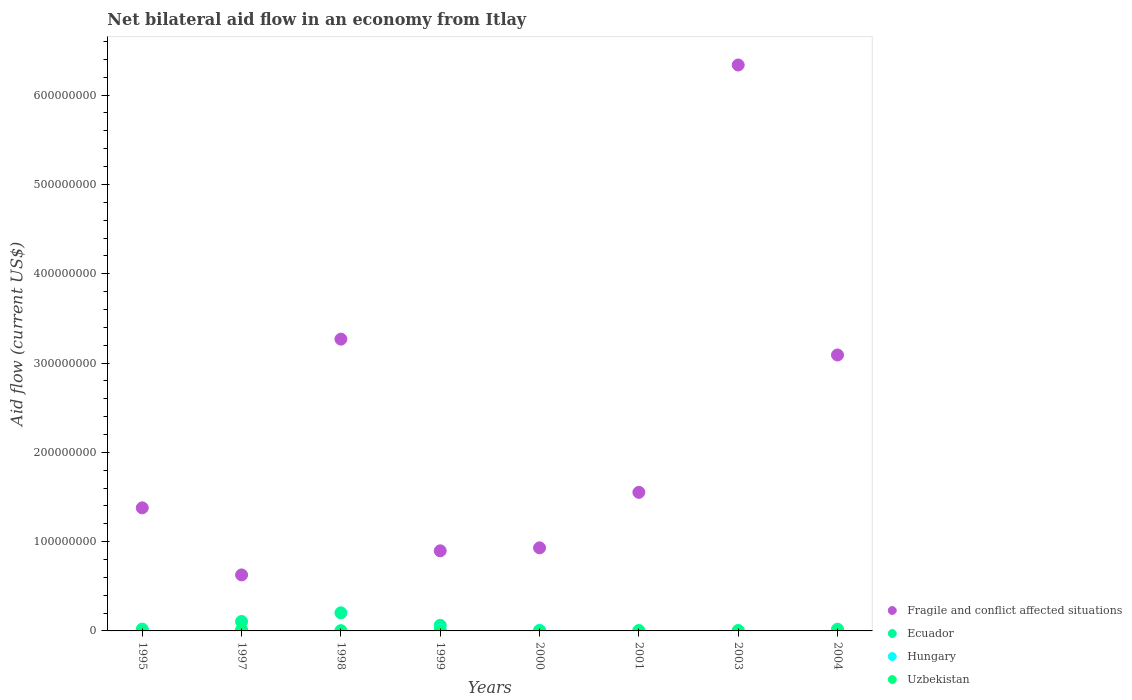How many different coloured dotlines are there?
Make the answer very short. 4. Is the number of dotlines equal to the number of legend labels?
Make the answer very short. No. Across all years, what is the maximum net bilateral aid flow in Hungary?
Your answer should be very brief. 8.90e+05. What is the total net bilateral aid flow in Ecuador in the graph?
Keep it short and to the point. 4.11e+07. What is the difference between the net bilateral aid flow in Uzbekistan in 1997 and that in 1998?
Offer a terse response. 1.13e+06. What is the difference between the net bilateral aid flow in Fragile and conflict affected situations in 1997 and the net bilateral aid flow in Ecuador in 1999?
Your answer should be very brief. 5.64e+07. What is the average net bilateral aid flow in Fragile and conflict affected situations per year?
Keep it short and to the point. 2.26e+08. In how many years, is the net bilateral aid flow in Fragile and conflict affected situations greater than 620000000 US$?
Provide a succinct answer. 1. What is the ratio of the net bilateral aid flow in Hungary in 1995 to that in 1999?
Your response must be concise. 0.37. Is the difference between the net bilateral aid flow in Uzbekistan in 1997 and 2003 greater than the difference between the net bilateral aid flow in Hungary in 1997 and 2003?
Offer a terse response. Yes. What is the difference between the highest and the second highest net bilateral aid flow in Fragile and conflict affected situations?
Offer a very short reply. 3.07e+08. What is the difference between the highest and the lowest net bilateral aid flow in Ecuador?
Provide a short and direct response. 2.03e+07. Does the net bilateral aid flow in Hungary monotonically increase over the years?
Keep it short and to the point. No. How many dotlines are there?
Your answer should be very brief. 4. Are the values on the major ticks of Y-axis written in scientific E-notation?
Offer a very short reply. No. Where does the legend appear in the graph?
Offer a very short reply. Bottom right. How many legend labels are there?
Your answer should be very brief. 4. What is the title of the graph?
Keep it short and to the point. Net bilateral aid flow in an economy from Itlay. What is the label or title of the X-axis?
Your answer should be very brief. Years. What is the Aid flow (current US$) in Fragile and conflict affected situations in 1995?
Keep it short and to the point. 1.38e+08. What is the Aid flow (current US$) of Ecuador in 1995?
Your response must be concise. 2.02e+06. What is the Aid flow (current US$) in Uzbekistan in 1995?
Your response must be concise. 10000. What is the Aid flow (current US$) of Fragile and conflict affected situations in 1997?
Your response must be concise. 6.27e+07. What is the Aid flow (current US$) of Ecuador in 1997?
Offer a very short reply. 1.06e+07. What is the Aid flow (current US$) of Hungary in 1997?
Offer a terse response. 2.60e+05. What is the Aid flow (current US$) of Uzbekistan in 1997?
Your answer should be very brief. 1.17e+06. What is the Aid flow (current US$) of Fragile and conflict affected situations in 1998?
Offer a very short reply. 3.27e+08. What is the Aid flow (current US$) in Ecuador in 1998?
Offer a very short reply. 2.03e+07. What is the Aid flow (current US$) of Hungary in 1998?
Give a very brief answer. 2.00e+05. What is the Aid flow (current US$) of Fragile and conflict affected situations in 1999?
Your response must be concise. 8.97e+07. What is the Aid flow (current US$) of Ecuador in 1999?
Offer a very short reply. 6.26e+06. What is the Aid flow (current US$) in Hungary in 1999?
Offer a terse response. 8.90e+05. What is the Aid flow (current US$) of Fragile and conflict affected situations in 2000?
Your answer should be very brief. 9.30e+07. What is the Aid flow (current US$) in Hungary in 2000?
Offer a terse response. 7.20e+05. What is the Aid flow (current US$) in Uzbekistan in 2000?
Offer a terse response. 10000. What is the Aid flow (current US$) of Fragile and conflict affected situations in 2001?
Your answer should be very brief. 1.55e+08. What is the Aid flow (current US$) of Ecuador in 2001?
Offer a very short reply. 0. What is the Aid flow (current US$) of Hungary in 2001?
Offer a terse response. 3.30e+05. What is the Aid flow (current US$) in Uzbekistan in 2001?
Your answer should be compact. 1.80e+05. What is the Aid flow (current US$) of Fragile and conflict affected situations in 2003?
Ensure brevity in your answer.  6.34e+08. What is the Aid flow (current US$) in Fragile and conflict affected situations in 2004?
Make the answer very short. 3.09e+08. What is the Aid flow (current US$) of Ecuador in 2004?
Provide a short and direct response. 1.93e+06. What is the Aid flow (current US$) in Hungary in 2004?
Offer a very short reply. 3.00e+04. What is the Aid flow (current US$) of Uzbekistan in 2004?
Provide a succinct answer. 10000. Across all years, what is the maximum Aid flow (current US$) of Fragile and conflict affected situations?
Give a very brief answer. 6.34e+08. Across all years, what is the maximum Aid flow (current US$) in Ecuador?
Your answer should be very brief. 2.03e+07. Across all years, what is the maximum Aid flow (current US$) in Hungary?
Offer a very short reply. 8.90e+05. Across all years, what is the maximum Aid flow (current US$) in Uzbekistan?
Keep it short and to the point. 1.17e+06. Across all years, what is the minimum Aid flow (current US$) in Fragile and conflict affected situations?
Your response must be concise. 6.27e+07. Across all years, what is the minimum Aid flow (current US$) of Ecuador?
Your answer should be very brief. 0. Across all years, what is the minimum Aid flow (current US$) of Uzbekistan?
Offer a very short reply. 10000. What is the total Aid flow (current US$) of Fragile and conflict affected situations in the graph?
Ensure brevity in your answer.  1.81e+09. What is the total Aid flow (current US$) in Ecuador in the graph?
Make the answer very short. 4.11e+07. What is the total Aid flow (current US$) in Hungary in the graph?
Offer a very short reply. 3.15e+06. What is the total Aid flow (current US$) in Uzbekistan in the graph?
Give a very brief answer. 1.70e+06. What is the difference between the Aid flow (current US$) of Fragile and conflict affected situations in 1995 and that in 1997?
Offer a terse response. 7.51e+07. What is the difference between the Aid flow (current US$) in Ecuador in 1995 and that in 1997?
Ensure brevity in your answer.  -8.59e+06. What is the difference between the Aid flow (current US$) of Uzbekistan in 1995 and that in 1997?
Offer a very short reply. -1.16e+06. What is the difference between the Aid flow (current US$) in Fragile and conflict affected situations in 1995 and that in 1998?
Your answer should be compact. -1.89e+08. What is the difference between the Aid flow (current US$) of Ecuador in 1995 and that in 1998?
Ensure brevity in your answer.  -1.83e+07. What is the difference between the Aid flow (current US$) in Uzbekistan in 1995 and that in 1998?
Provide a short and direct response. -3.00e+04. What is the difference between the Aid flow (current US$) in Fragile and conflict affected situations in 1995 and that in 1999?
Your answer should be very brief. 4.81e+07. What is the difference between the Aid flow (current US$) in Ecuador in 1995 and that in 1999?
Offer a terse response. -4.24e+06. What is the difference between the Aid flow (current US$) in Hungary in 1995 and that in 1999?
Provide a succinct answer. -5.60e+05. What is the difference between the Aid flow (current US$) in Uzbekistan in 1995 and that in 1999?
Your answer should be very brief. -3.00e+04. What is the difference between the Aid flow (current US$) of Fragile and conflict affected situations in 1995 and that in 2000?
Offer a very short reply. 4.48e+07. What is the difference between the Aid flow (current US$) in Hungary in 1995 and that in 2000?
Make the answer very short. -3.90e+05. What is the difference between the Aid flow (current US$) of Fragile and conflict affected situations in 1995 and that in 2001?
Ensure brevity in your answer.  -1.74e+07. What is the difference between the Aid flow (current US$) in Hungary in 1995 and that in 2001?
Your answer should be compact. 0. What is the difference between the Aid flow (current US$) of Uzbekistan in 1995 and that in 2001?
Your answer should be very brief. -1.70e+05. What is the difference between the Aid flow (current US$) of Fragile and conflict affected situations in 1995 and that in 2003?
Provide a short and direct response. -4.96e+08. What is the difference between the Aid flow (current US$) in Fragile and conflict affected situations in 1995 and that in 2004?
Ensure brevity in your answer.  -1.71e+08. What is the difference between the Aid flow (current US$) in Fragile and conflict affected situations in 1997 and that in 1998?
Give a very brief answer. -2.64e+08. What is the difference between the Aid flow (current US$) of Ecuador in 1997 and that in 1998?
Provide a succinct answer. -9.68e+06. What is the difference between the Aid flow (current US$) of Hungary in 1997 and that in 1998?
Offer a very short reply. 6.00e+04. What is the difference between the Aid flow (current US$) of Uzbekistan in 1997 and that in 1998?
Ensure brevity in your answer.  1.13e+06. What is the difference between the Aid flow (current US$) in Fragile and conflict affected situations in 1997 and that in 1999?
Offer a very short reply. -2.70e+07. What is the difference between the Aid flow (current US$) of Ecuador in 1997 and that in 1999?
Ensure brevity in your answer.  4.35e+06. What is the difference between the Aid flow (current US$) in Hungary in 1997 and that in 1999?
Offer a very short reply. -6.30e+05. What is the difference between the Aid flow (current US$) in Uzbekistan in 1997 and that in 1999?
Make the answer very short. 1.13e+06. What is the difference between the Aid flow (current US$) in Fragile and conflict affected situations in 1997 and that in 2000?
Offer a terse response. -3.03e+07. What is the difference between the Aid flow (current US$) in Hungary in 1997 and that in 2000?
Give a very brief answer. -4.60e+05. What is the difference between the Aid flow (current US$) in Uzbekistan in 1997 and that in 2000?
Your answer should be very brief. 1.16e+06. What is the difference between the Aid flow (current US$) in Fragile and conflict affected situations in 1997 and that in 2001?
Provide a short and direct response. -9.25e+07. What is the difference between the Aid flow (current US$) of Hungary in 1997 and that in 2001?
Give a very brief answer. -7.00e+04. What is the difference between the Aid flow (current US$) in Uzbekistan in 1997 and that in 2001?
Keep it short and to the point. 9.90e+05. What is the difference between the Aid flow (current US$) of Fragile and conflict affected situations in 1997 and that in 2003?
Provide a succinct answer. -5.71e+08. What is the difference between the Aid flow (current US$) in Hungary in 1997 and that in 2003?
Your response must be concise. -1.30e+05. What is the difference between the Aid flow (current US$) in Uzbekistan in 1997 and that in 2003?
Provide a succinct answer. 9.30e+05. What is the difference between the Aid flow (current US$) of Fragile and conflict affected situations in 1997 and that in 2004?
Offer a very short reply. -2.46e+08. What is the difference between the Aid flow (current US$) in Ecuador in 1997 and that in 2004?
Your answer should be very brief. 8.68e+06. What is the difference between the Aid flow (current US$) of Uzbekistan in 1997 and that in 2004?
Provide a short and direct response. 1.16e+06. What is the difference between the Aid flow (current US$) of Fragile and conflict affected situations in 1998 and that in 1999?
Offer a terse response. 2.37e+08. What is the difference between the Aid flow (current US$) in Ecuador in 1998 and that in 1999?
Your answer should be compact. 1.40e+07. What is the difference between the Aid flow (current US$) in Hungary in 1998 and that in 1999?
Offer a terse response. -6.90e+05. What is the difference between the Aid flow (current US$) of Fragile and conflict affected situations in 1998 and that in 2000?
Your answer should be compact. 2.34e+08. What is the difference between the Aid flow (current US$) in Hungary in 1998 and that in 2000?
Make the answer very short. -5.20e+05. What is the difference between the Aid flow (current US$) in Uzbekistan in 1998 and that in 2000?
Keep it short and to the point. 3.00e+04. What is the difference between the Aid flow (current US$) in Fragile and conflict affected situations in 1998 and that in 2001?
Your answer should be compact. 1.72e+08. What is the difference between the Aid flow (current US$) of Uzbekistan in 1998 and that in 2001?
Your answer should be very brief. -1.40e+05. What is the difference between the Aid flow (current US$) in Fragile and conflict affected situations in 1998 and that in 2003?
Your answer should be compact. -3.07e+08. What is the difference between the Aid flow (current US$) of Hungary in 1998 and that in 2003?
Your answer should be very brief. -1.90e+05. What is the difference between the Aid flow (current US$) in Fragile and conflict affected situations in 1998 and that in 2004?
Your response must be concise. 1.77e+07. What is the difference between the Aid flow (current US$) of Ecuador in 1998 and that in 2004?
Offer a terse response. 1.84e+07. What is the difference between the Aid flow (current US$) of Hungary in 1998 and that in 2004?
Keep it short and to the point. 1.70e+05. What is the difference between the Aid flow (current US$) in Fragile and conflict affected situations in 1999 and that in 2000?
Your response must be concise. -3.33e+06. What is the difference between the Aid flow (current US$) of Fragile and conflict affected situations in 1999 and that in 2001?
Offer a terse response. -6.55e+07. What is the difference between the Aid flow (current US$) in Hungary in 1999 and that in 2001?
Ensure brevity in your answer.  5.60e+05. What is the difference between the Aid flow (current US$) in Uzbekistan in 1999 and that in 2001?
Your answer should be compact. -1.40e+05. What is the difference between the Aid flow (current US$) in Fragile and conflict affected situations in 1999 and that in 2003?
Ensure brevity in your answer.  -5.44e+08. What is the difference between the Aid flow (current US$) of Hungary in 1999 and that in 2003?
Your answer should be very brief. 5.00e+05. What is the difference between the Aid flow (current US$) of Uzbekistan in 1999 and that in 2003?
Your response must be concise. -2.00e+05. What is the difference between the Aid flow (current US$) in Fragile and conflict affected situations in 1999 and that in 2004?
Make the answer very short. -2.19e+08. What is the difference between the Aid flow (current US$) of Ecuador in 1999 and that in 2004?
Your answer should be compact. 4.33e+06. What is the difference between the Aid flow (current US$) in Hungary in 1999 and that in 2004?
Ensure brevity in your answer.  8.60e+05. What is the difference between the Aid flow (current US$) in Fragile and conflict affected situations in 2000 and that in 2001?
Make the answer very short. -6.21e+07. What is the difference between the Aid flow (current US$) in Hungary in 2000 and that in 2001?
Offer a very short reply. 3.90e+05. What is the difference between the Aid flow (current US$) of Uzbekistan in 2000 and that in 2001?
Your response must be concise. -1.70e+05. What is the difference between the Aid flow (current US$) of Fragile and conflict affected situations in 2000 and that in 2003?
Keep it short and to the point. -5.41e+08. What is the difference between the Aid flow (current US$) of Uzbekistan in 2000 and that in 2003?
Keep it short and to the point. -2.30e+05. What is the difference between the Aid flow (current US$) in Fragile and conflict affected situations in 2000 and that in 2004?
Provide a short and direct response. -2.16e+08. What is the difference between the Aid flow (current US$) in Hungary in 2000 and that in 2004?
Your answer should be very brief. 6.90e+05. What is the difference between the Aid flow (current US$) in Uzbekistan in 2000 and that in 2004?
Your response must be concise. 0. What is the difference between the Aid flow (current US$) in Fragile and conflict affected situations in 2001 and that in 2003?
Provide a short and direct response. -4.79e+08. What is the difference between the Aid flow (current US$) of Hungary in 2001 and that in 2003?
Make the answer very short. -6.00e+04. What is the difference between the Aid flow (current US$) of Uzbekistan in 2001 and that in 2003?
Keep it short and to the point. -6.00e+04. What is the difference between the Aid flow (current US$) in Fragile and conflict affected situations in 2001 and that in 2004?
Offer a terse response. -1.54e+08. What is the difference between the Aid flow (current US$) of Uzbekistan in 2001 and that in 2004?
Ensure brevity in your answer.  1.70e+05. What is the difference between the Aid flow (current US$) in Fragile and conflict affected situations in 2003 and that in 2004?
Offer a very short reply. 3.25e+08. What is the difference between the Aid flow (current US$) in Uzbekistan in 2003 and that in 2004?
Offer a terse response. 2.30e+05. What is the difference between the Aid flow (current US$) in Fragile and conflict affected situations in 1995 and the Aid flow (current US$) in Ecuador in 1997?
Your answer should be compact. 1.27e+08. What is the difference between the Aid flow (current US$) of Fragile and conflict affected situations in 1995 and the Aid flow (current US$) of Hungary in 1997?
Your response must be concise. 1.38e+08. What is the difference between the Aid flow (current US$) in Fragile and conflict affected situations in 1995 and the Aid flow (current US$) in Uzbekistan in 1997?
Make the answer very short. 1.37e+08. What is the difference between the Aid flow (current US$) in Ecuador in 1995 and the Aid flow (current US$) in Hungary in 1997?
Give a very brief answer. 1.76e+06. What is the difference between the Aid flow (current US$) of Ecuador in 1995 and the Aid flow (current US$) of Uzbekistan in 1997?
Keep it short and to the point. 8.50e+05. What is the difference between the Aid flow (current US$) in Hungary in 1995 and the Aid flow (current US$) in Uzbekistan in 1997?
Offer a very short reply. -8.40e+05. What is the difference between the Aid flow (current US$) in Fragile and conflict affected situations in 1995 and the Aid flow (current US$) in Ecuador in 1998?
Ensure brevity in your answer.  1.18e+08. What is the difference between the Aid flow (current US$) of Fragile and conflict affected situations in 1995 and the Aid flow (current US$) of Hungary in 1998?
Your answer should be very brief. 1.38e+08. What is the difference between the Aid flow (current US$) of Fragile and conflict affected situations in 1995 and the Aid flow (current US$) of Uzbekistan in 1998?
Ensure brevity in your answer.  1.38e+08. What is the difference between the Aid flow (current US$) in Ecuador in 1995 and the Aid flow (current US$) in Hungary in 1998?
Provide a succinct answer. 1.82e+06. What is the difference between the Aid flow (current US$) of Ecuador in 1995 and the Aid flow (current US$) of Uzbekistan in 1998?
Your answer should be compact. 1.98e+06. What is the difference between the Aid flow (current US$) in Fragile and conflict affected situations in 1995 and the Aid flow (current US$) in Ecuador in 1999?
Your answer should be very brief. 1.32e+08. What is the difference between the Aid flow (current US$) of Fragile and conflict affected situations in 1995 and the Aid flow (current US$) of Hungary in 1999?
Make the answer very short. 1.37e+08. What is the difference between the Aid flow (current US$) in Fragile and conflict affected situations in 1995 and the Aid flow (current US$) in Uzbekistan in 1999?
Offer a terse response. 1.38e+08. What is the difference between the Aid flow (current US$) of Ecuador in 1995 and the Aid flow (current US$) of Hungary in 1999?
Offer a very short reply. 1.13e+06. What is the difference between the Aid flow (current US$) in Ecuador in 1995 and the Aid flow (current US$) in Uzbekistan in 1999?
Ensure brevity in your answer.  1.98e+06. What is the difference between the Aid flow (current US$) of Hungary in 1995 and the Aid flow (current US$) of Uzbekistan in 1999?
Offer a very short reply. 2.90e+05. What is the difference between the Aid flow (current US$) of Fragile and conflict affected situations in 1995 and the Aid flow (current US$) of Hungary in 2000?
Provide a succinct answer. 1.37e+08. What is the difference between the Aid flow (current US$) in Fragile and conflict affected situations in 1995 and the Aid flow (current US$) in Uzbekistan in 2000?
Keep it short and to the point. 1.38e+08. What is the difference between the Aid flow (current US$) of Ecuador in 1995 and the Aid flow (current US$) of Hungary in 2000?
Provide a short and direct response. 1.30e+06. What is the difference between the Aid flow (current US$) in Ecuador in 1995 and the Aid flow (current US$) in Uzbekistan in 2000?
Your answer should be compact. 2.01e+06. What is the difference between the Aid flow (current US$) in Hungary in 1995 and the Aid flow (current US$) in Uzbekistan in 2000?
Ensure brevity in your answer.  3.20e+05. What is the difference between the Aid flow (current US$) of Fragile and conflict affected situations in 1995 and the Aid flow (current US$) of Hungary in 2001?
Offer a very short reply. 1.38e+08. What is the difference between the Aid flow (current US$) in Fragile and conflict affected situations in 1995 and the Aid flow (current US$) in Uzbekistan in 2001?
Provide a succinct answer. 1.38e+08. What is the difference between the Aid flow (current US$) in Ecuador in 1995 and the Aid flow (current US$) in Hungary in 2001?
Your response must be concise. 1.69e+06. What is the difference between the Aid flow (current US$) of Ecuador in 1995 and the Aid flow (current US$) of Uzbekistan in 2001?
Ensure brevity in your answer.  1.84e+06. What is the difference between the Aid flow (current US$) of Fragile and conflict affected situations in 1995 and the Aid flow (current US$) of Hungary in 2003?
Ensure brevity in your answer.  1.37e+08. What is the difference between the Aid flow (current US$) in Fragile and conflict affected situations in 1995 and the Aid flow (current US$) in Uzbekistan in 2003?
Make the answer very short. 1.38e+08. What is the difference between the Aid flow (current US$) of Ecuador in 1995 and the Aid flow (current US$) of Hungary in 2003?
Ensure brevity in your answer.  1.63e+06. What is the difference between the Aid flow (current US$) in Ecuador in 1995 and the Aid flow (current US$) in Uzbekistan in 2003?
Your answer should be compact. 1.78e+06. What is the difference between the Aid flow (current US$) of Fragile and conflict affected situations in 1995 and the Aid flow (current US$) of Ecuador in 2004?
Keep it short and to the point. 1.36e+08. What is the difference between the Aid flow (current US$) of Fragile and conflict affected situations in 1995 and the Aid flow (current US$) of Hungary in 2004?
Keep it short and to the point. 1.38e+08. What is the difference between the Aid flow (current US$) in Fragile and conflict affected situations in 1995 and the Aid flow (current US$) in Uzbekistan in 2004?
Keep it short and to the point. 1.38e+08. What is the difference between the Aid flow (current US$) in Ecuador in 1995 and the Aid flow (current US$) in Hungary in 2004?
Make the answer very short. 1.99e+06. What is the difference between the Aid flow (current US$) in Ecuador in 1995 and the Aid flow (current US$) in Uzbekistan in 2004?
Your answer should be compact. 2.01e+06. What is the difference between the Aid flow (current US$) in Hungary in 1995 and the Aid flow (current US$) in Uzbekistan in 2004?
Your answer should be compact. 3.20e+05. What is the difference between the Aid flow (current US$) in Fragile and conflict affected situations in 1997 and the Aid flow (current US$) in Ecuador in 1998?
Your answer should be compact. 4.24e+07. What is the difference between the Aid flow (current US$) of Fragile and conflict affected situations in 1997 and the Aid flow (current US$) of Hungary in 1998?
Offer a very short reply. 6.25e+07. What is the difference between the Aid flow (current US$) of Fragile and conflict affected situations in 1997 and the Aid flow (current US$) of Uzbekistan in 1998?
Keep it short and to the point. 6.27e+07. What is the difference between the Aid flow (current US$) in Ecuador in 1997 and the Aid flow (current US$) in Hungary in 1998?
Give a very brief answer. 1.04e+07. What is the difference between the Aid flow (current US$) in Ecuador in 1997 and the Aid flow (current US$) in Uzbekistan in 1998?
Offer a terse response. 1.06e+07. What is the difference between the Aid flow (current US$) in Fragile and conflict affected situations in 1997 and the Aid flow (current US$) in Ecuador in 1999?
Your answer should be very brief. 5.64e+07. What is the difference between the Aid flow (current US$) in Fragile and conflict affected situations in 1997 and the Aid flow (current US$) in Hungary in 1999?
Your answer should be very brief. 6.18e+07. What is the difference between the Aid flow (current US$) in Fragile and conflict affected situations in 1997 and the Aid flow (current US$) in Uzbekistan in 1999?
Provide a short and direct response. 6.27e+07. What is the difference between the Aid flow (current US$) of Ecuador in 1997 and the Aid flow (current US$) of Hungary in 1999?
Your response must be concise. 9.72e+06. What is the difference between the Aid flow (current US$) in Ecuador in 1997 and the Aid flow (current US$) in Uzbekistan in 1999?
Ensure brevity in your answer.  1.06e+07. What is the difference between the Aid flow (current US$) in Hungary in 1997 and the Aid flow (current US$) in Uzbekistan in 1999?
Make the answer very short. 2.20e+05. What is the difference between the Aid flow (current US$) of Fragile and conflict affected situations in 1997 and the Aid flow (current US$) of Hungary in 2000?
Give a very brief answer. 6.20e+07. What is the difference between the Aid flow (current US$) in Fragile and conflict affected situations in 1997 and the Aid flow (current US$) in Uzbekistan in 2000?
Your answer should be very brief. 6.27e+07. What is the difference between the Aid flow (current US$) of Ecuador in 1997 and the Aid flow (current US$) of Hungary in 2000?
Your answer should be very brief. 9.89e+06. What is the difference between the Aid flow (current US$) in Ecuador in 1997 and the Aid flow (current US$) in Uzbekistan in 2000?
Your answer should be very brief. 1.06e+07. What is the difference between the Aid flow (current US$) of Hungary in 1997 and the Aid flow (current US$) of Uzbekistan in 2000?
Provide a succinct answer. 2.50e+05. What is the difference between the Aid flow (current US$) in Fragile and conflict affected situations in 1997 and the Aid flow (current US$) in Hungary in 2001?
Provide a short and direct response. 6.24e+07. What is the difference between the Aid flow (current US$) of Fragile and conflict affected situations in 1997 and the Aid flow (current US$) of Uzbekistan in 2001?
Make the answer very short. 6.25e+07. What is the difference between the Aid flow (current US$) in Ecuador in 1997 and the Aid flow (current US$) in Hungary in 2001?
Provide a succinct answer. 1.03e+07. What is the difference between the Aid flow (current US$) of Ecuador in 1997 and the Aid flow (current US$) of Uzbekistan in 2001?
Your answer should be very brief. 1.04e+07. What is the difference between the Aid flow (current US$) of Hungary in 1997 and the Aid flow (current US$) of Uzbekistan in 2001?
Provide a short and direct response. 8.00e+04. What is the difference between the Aid flow (current US$) of Fragile and conflict affected situations in 1997 and the Aid flow (current US$) of Hungary in 2003?
Offer a terse response. 6.23e+07. What is the difference between the Aid flow (current US$) in Fragile and conflict affected situations in 1997 and the Aid flow (current US$) in Uzbekistan in 2003?
Your answer should be compact. 6.25e+07. What is the difference between the Aid flow (current US$) in Ecuador in 1997 and the Aid flow (current US$) in Hungary in 2003?
Offer a terse response. 1.02e+07. What is the difference between the Aid flow (current US$) in Ecuador in 1997 and the Aid flow (current US$) in Uzbekistan in 2003?
Provide a succinct answer. 1.04e+07. What is the difference between the Aid flow (current US$) of Hungary in 1997 and the Aid flow (current US$) of Uzbekistan in 2003?
Ensure brevity in your answer.  2.00e+04. What is the difference between the Aid flow (current US$) in Fragile and conflict affected situations in 1997 and the Aid flow (current US$) in Ecuador in 2004?
Your answer should be compact. 6.08e+07. What is the difference between the Aid flow (current US$) in Fragile and conflict affected situations in 1997 and the Aid flow (current US$) in Hungary in 2004?
Give a very brief answer. 6.27e+07. What is the difference between the Aid flow (current US$) of Fragile and conflict affected situations in 1997 and the Aid flow (current US$) of Uzbekistan in 2004?
Your answer should be very brief. 6.27e+07. What is the difference between the Aid flow (current US$) of Ecuador in 1997 and the Aid flow (current US$) of Hungary in 2004?
Ensure brevity in your answer.  1.06e+07. What is the difference between the Aid flow (current US$) in Ecuador in 1997 and the Aid flow (current US$) in Uzbekistan in 2004?
Keep it short and to the point. 1.06e+07. What is the difference between the Aid flow (current US$) of Fragile and conflict affected situations in 1998 and the Aid flow (current US$) of Ecuador in 1999?
Offer a very short reply. 3.20e+08. What is the difference between the Aid flow (current US$) in Fragile and conflict affected situations in 1998 and the Aid flow (current US$) in Hungary in 1999?
Your response must be concise. 3.26e+08. What is the difference between the Aid flow (current US$) of Fragile and conflict affected situations in 1998 and the Aid flow (current US$) of Uzbekistan in 1999?
Make the answer very short. 3.27e+08. What is the difference between the Aid flow (current US$) of Ecuador in 1998 and the Aid flow (current US$) of Hungary in 1999?
Make the answer very short. 1.94e+07. What is the difference between the Aid flow (current US$) in Ecuador in 1998 and the Aid flow (current US$) in Uzbekistan in 1999?
Ensure brevity in your answer.  2.02e+07. What is the difference between the Aid flow (current US$) in Fragile and conflict affected situations in 1998 and the Aid flow (current US$) in Hungary in 2000?
Offer a very short reply. 3.26e+08. What is the difference between the Aid flow (current US$) in Fragile and conflict affected situations in 1998 and the Aid flow (current US$) in Uzbekistan in 2000?
Your answer should be compact. 3.27e+08. What is the difference between the Aid flow (current US$) of Ecuador in 1998 and the Aid flow (current US$) of Hungary in 2000?
Make the answer very short. 1.96e+07. What is the difference between the Aid flow (current US$) in Ecuador in 1998 and the Aid flow (current US$) in Uzbekistan in 2000?
Your answer should be very brief. 2.03e+07. What is the difference between the Aid flow (current US$) of Fragile and conflict affected situations in 1998 and the Aid flow (current US$) of Hungary in 2001?
Provide a short and direct response. 3.26e+08. What is the difference between the Aid flow (current US$) of Fragile and conflict affected situations in 1998 and the Aid flow (current US$) of Uzbekistan in 2001?
Your response must be concise. 3.27e+08. What is the difference between the Aid flow (current US$) in Ecuador in 1998 and the Aid flow (current US$) in Hungary in 2001?
Offer a terse response. 2.00e+07. What is the difference between the Aid flow (current US$) of Ecuador in 1998 and the Aid flow (current US$) of Uzbekistan in 2001?
Your response must be concise. 2.01e+07. What is the difference between the Aid flow (current US$) in Fragile and conflict affected situations in 1998 and the Aid flow (current US$) in Hungary in 2003?
Make the answer very short. 3.26e+08. What is the difference between the Aid flow (current US$) of Fragile and conflict affected situations in 1998 and the Aid flow (current US$) of Uzbekistan in 2003?
Your answer should be compact. 3.26e+08. What is the difference between the Aid flow (current US$) in Ecuador in 1998 and the Aid flow (current US$) in Hungary in 2003?
Give a very brief answer. 1.99e+07. What is the difference between the Aid flow (current US$) in Ecuador in 1998 and the Aid flow (current US$) in Uzbekistan in 2003?
Offer a very short reply. 2.00e+07. What is the difference between the Aid flow (current US$) in Fragile and conflict affected situations in 1998 and the Aid flow (current US$) in Ecuador in 2004?
Make the answer very short. 3.25e+08. What is the difference between the Aid flow (current US$) of Fragile and conflict affected situations in 1998 and the Aid flow (current US$) of Hungary in 2004?
Give a very brief answer. 3.27e+08. What is the difference between the Aid flow (current US$) in Fragile and conflict affected situations in 1998 and the Aid flow (current US$) in Uzbekistan in 2004?
Keep it short and to the point. 3.27e+08. What is the difference between the Aid flow (current US$) of Ecuador in 1998 and the Aid flow (current US$) of Hungary in 2004?
Offer a very short reply. 2.03e+07. What is the difference between the Aid flow (current US$) in Ecuador in 1998 and the Aid flow (current US$) in Uzbekistan in 2004?
Offer a terse response. 2.03e+07. What is the difference between the Aid flow (current US$) in Fragile and conflict affected situations in 1999 and the Aid flow (current US$) in Hungary in 2000?
Make the answer very short. 8.90e+07. What is the difference between the Aid flow (current US$) of Fragile and conflict affected situations in 1999 and the Aid flow (current US$) of Uzbekistan in 2000?
Ensure brevity in your answer.  8.97e+07. What is the difference between the Aid flow (current US$) in Ecuador in 1999 and the Aid flow (current US$) in Hungary in 2000?
Keep it short and to the point. 5.54e+06. What is the difference between the Aid flow (current US$) in Ecuador in 1999 and the Aid flow (current US$) in Uzbekistan in 2000?
Ensure brevity in your answer.  6.25e+06. What is the difference between the Aid flow (current US$) of Hungary in 1999 and the Aid flow (current US$) of Uzbekistan in 2000?
Your answer should be very brief. 8.80e+05. What is the difference between the Aid flow (current US$) of Fragile and conflict affected situations in 1999 and the Aid flow (current US$) of Hungary in 2001?
Your response must be concise. 8.94e+07. What is the difference between the Aid flow (current US$) in Fragile and conflict affected situations in 1999 and the Aid flow (current US$) in Uzbekistan in 2001?
Offer a very short reply. 8.95e+07. What is the difference between the Aid flow (current US$) in Ecuador in 1999 and the Aid flow (current US$) in Hungary in 2001?
Offer a very short reply. 5.93e+06. What is the difference between the Aid flow (current US$) in Ecuador in 1999 and the Aid flow (current US$) in Uzbekistan in 2001?
Give a very brief answer. 6.08e+06. What is the difference between the Aid flow (current US$) of Hungary in 1999 and the Aid flow (current US$) of Uzbekistan in 2001?
Give a very brief answer. 7.10e+05. What is the difference between the Aid flow (current US$) of Fragile and conflict affected situations in 1999 and the Aid flow (current US$) of Hungary in 2003?
Ensure brevity in your answer.  8.93e+07. What is the difference between the Aid flow (current US$) of Fragile and conflict affected situations in 1999 and the Aid flow (current US$) of Uzbekistan in 2003?
Ensure brevity in your answer.  8.95e+07. What is the difference between the Aid flow (current US$) in Ecuador in 1999 and the Aid flow (current US$) in Hungary in 2003?
Make the answer very short. 5.87e+06. What is the difference between the Aid flow (current US$) in Ecuador in 1999 and the Aid flow (current US$) in Uzbekistan in 2003?
Keep it short and to the point. 6.02e+06. What is the difference between the Aid flow (current US$) in Hungary in 1999 and the Aid flow (current US$) in Uzbekistan in 2003?
Keep it short and to the point. 6.50e+05. What is the difference between the Aid flow (current US$) in Fragile and conflict affected situations in 1999 and the Aid flow (current US$) in Ecuador in 2004?
Offer a terse response. 8.78e+07. What is the difference between the Aid flow (current US$) of Fragile and conflict affected situations in 1999 and the Aid flow (current US$) of Hungary in 2004?
Give a very brief answer. 8.97e+07. What is the difference between the Aid flow (current US$) of Fragile and conflict affected situations in 1999 and the Aid flow (current US$) of Uzbekistan in 2004?
Keep it short and to the point. 8.97e+07. What is the difference between the Aid flow (current US$) of Ecuador in 1999 and the Aid flow (current US$) of Hungary in 2004?
Make the answer very short. 6.23e+06. What is the difference between the Aid flow (current US$) in Ecuador in 1999 and the Aid flow (current US$) in Uzbekistan in 2004?
Make the answer very short. 6.25e+06. What is the difference between the Aid flow (current US$) in Hungary in 1999 and the Aid flow (current US$) in Uzbekistan in 2004?
Your response must be concise. 8.80e+05. What is the difference between the Aid flow (current US$) of Fragile and conflict affected situations in 2000 and the Aid flow (current US$) of Hungary in 2001?
Your answer should be compact. 9.27e+07. What is the difference between the Aid flow (current US$) of Fragile and conflict affected situations in 2000 and the Aid flow (current US$) of Uzbekistan in 2001?
Keep it short and to the point. 9.29e+07. What is the difference between the Aid flow (current US$) of Hungary in 2000 and the Aid flow (current US$) of Uzbekistan in 2001?
Make the answer very short. 5.40e+05. What is the difference between the Aid flow (current US$) of Fragile and conflict affected situations in 2000 and the Aid flow (current US$) of Hungary in 2003?
Offer a very short reply. 9.26e+07. What is the difference between the Aid flow (current US$) of Fragile and conflict affected situations in 2000 and the Aid flow (current US$) of Uzbekistan in 2003?
Provide a succinct answer. 9.28e+07. What is the difference between the Aid flow (current US$) in Fragile and conflict affected situations in 2000 and the Aid flow (current US$) in Ecuador in 2004?
Keep it short and to the point. 9.11e+07. What is the difference between the Aid flow (current US$) of Fragile and conflict affected situations in 2000 and the Aid flow (current US$) of Hungary in 2004?
Keep it short and to the point. 9.30e+07. What is the difference between the Aid flow (current US$) of Fragile and conflict affected situations in 2000 and the Aid flow (current US$) of Uzbekistan in 2004?
Provide a succinct answer. 9.30e+07. What is the difference between the Aid flow (current US$) in Hungary in 2000 and the Aid flow (current US$) in Uzbekistan in 2004?
Offer a very short reply. 7.10e+05. What is the difference between the Aid flow (current US$) in Fragile and conflict affected situations in 2001 and the Aid flow (current US$) in Hungary in 2003?
Your response must be concise. 1.55e+08. What is the difference between the Aid flow (current US$) of Fragile and conflict affected situations in 2001 and the Aid flow (current US$) of Uzbekistan in 2003?
Your answer should be very brief. 1.55e+08. What is the difference between the Aid flow (current US$) of Hungary in 2001 and the Aid flow (current US$) of Uzbekistan in 2003?
Provide a succinct answer. 9.00e+04. What is the difference between the Aid flow (current US$) in Fragile and conflict affected situations in 2001 and the Aid flow (current US$) in Ecuador in 2004?
Your response must be concise. 1.53e+08. What is the difference between the Aid flow (current US$) in Fragile and conflict affected situations in 2001 and the Aid flow (current US$) in Hungary in 2004?
Give a very brief answer. 1.55e+08. What is the difference between the Aid flow (current US$) in Fragile and conflict affected situations in 2001 and the Aid flow (current US$) in Uzbekistan in 2004?
Provide a short and direct response. 1.55e+08. What is the difference between the Aid flow (current US$) in Hungary in 2001 and the Aid flow (current US$) in Uzbekistan in 2004?
Give a very brief answer. 3.20e+05. What is the difference between the Aid flow (current US$) of Fragile and conflict affected situations in 2003 and the Aid flow (current US$) of Ecuador in 2004?
Your answer should be compact. 6.32e+08. What is the difference between the Aid flow (current US$) in Fragile and conflict affected situations in 2003 and the Aid flow (current US$) in Hungary in 2004?
Offer a very short reply. 6.34e+08. What is the difference between the Aid flow (current US$) in Fragile and conflict affected situations in 2003 and the Aid flow (current US$) in Uzbekistan in 2004?
Provide a short and direct response. 6.34e+08. What is the average Aid flow (current US$) of Fragile and conflict affected situations per year?
Your answer should be very brief. 2.26e+08. What is the average Aid flow (current US$) of Ecuador per year?
Offer a very short reply. 5.14e+06. What is the average Aid flow (current US$) of Hungary per year?
Your response must be concise. 3.94e+05. What is the average Aid flow (current US$) of Uzbekistan per year?
Give a very brief answer. 2.12e+05. In the year 1995, what is the difference between the Aid flow (current US$) of Fragile and conflict affected situations and Aid flow (current US$) of Ecuador?
Offer a terse response. 1.36e+08. In the year 1995, what is the difference between the Aid flow (current US$) of Fragile and conflict affected situations and Aid flow (current US$) of Hungary?
Make the answer very short. 1.38e+08. In the year 1995, what is the difference between the Aid flow (current US$) of Fragile and conflict affected situations and Aid flow (current US$) of Uzbekistan?
Provide a succinct answer. 1.38e+08. In the year 1995, what is the difference between the Aid flow (current US$) in Ecuador and Aid flow (current US$) in Hungary?
Give a very brief answer. 1.69e+06. In the year 1995, what is the difference between the Aid flow (current US$) of Ecuador and Aid flow (current US$) of Uzbekistan?
Offer a very short reply. 2.01e+06. In the year 1997, what is the difference between the Aid flow (current US$) of Fragile and conflict affected situations and Aid flow (current US$) of Ecuador?
Offer a very short reply. 5.21e+07. In the year 1997, what is the difference between the Aid flow (current US$) in Fragile and conflict affected situations and Aid flow (current US$) in Hungary?
Offer a very short reply. 6.24e+07. In the year 1997, what is the difference between the Aid flow (current US$) in Fragile and conflict affected situations and Aid flow (current US$) in Uzbekistan?
Ensure brevity in your answer.  6.15e+07. In the year 1997, what is the difference between the Aid flow (current US$) of Ecuador and Aid flow (current US$) of Hungary?
Offer a terse response. 1.04e+07. In the year 1997, what is the difference between the Aid flow (current US$) in Ecuador and Aid flow (current US$) in Uzbekistan?
Provide a short and direct response. 9.44e+06. In the year 1997, what is the difference between the Aid flow (current US$) of Hungary and Aid flow (current US$) of Uzbekistan?
Provide a short and direct response. -9.10e+05. In the year 1998, what is the difference between the Aid flow (current US$) of Fragile and conflict affected situations and Aid flow (current US$) of Ecuador?
Keep it short and to the point. 3.06e+08. In the year 1998, what is the difference between the Aid flow (current US$) of Fragile and conflict affected situations and Aid flow (current US$) of Hungary?
Offer a terse response. 3.27e+08. In the year 1998, what is the difference between the Aid flow (current US$) in Fragile and conflict affected situations and Aid flow (current US$) in Uzbekistan?
Provide a succinct answer. 3.27e+08. In the year 1998, what is the difference between the Aid flow (current US$) of Ecuador and Aid flow (current US$) of Hungary?
Ensure brevity in your answer.  2.01e+07. In the year 1998, what is the difference between the Aid flow (current US$) in Ecuador and Aid flow (current US$) in Uzbekistan?
Offer a very short reply. 2.02e+07. In the year 1998, what is the difference between the Aid flow (current US$) of Hungary and Aid flow (current US$) of Uzbekistan?
Your answer should be compact. 1.60e+05. In the year 1999, what is the difference between the Aid flow (current US$) of Fragile and conflict affected situations and Aid flow (current US$) of Ecuador?
Keep it short and to the point. 8.34e+07. In the year 1999, what is the difference between the Aid flow (current US$) in Fragile and conflict affected situations and Aid flow (current US$) in Hungary?
Your answer should be compact. 8.88e+07. In the year 1999, what is the difference between the Aid flow (current US$) of Fragile and conflict affected situations and Aid flow (current US$) of Uzbekistan?
Make the answer very short. 8.97e+07. In the year 1999, what is the difference between the Aid flow (current US$) of Ecuador and Aid flow (current US$) of Hungary?
Provide a succinct answer. 5.37e+06. In the year 1999, what is the difference between the Aid flow (current US$) of Ecuador and Aid flow (current US$) of Uzbekistan?
Provide a short and direct response. 6.22e+06. In the year 1999, what is the difference between the Aid flow (current US$) in Hungary and Aid flow (current US$) in Uzbekistan?
Your response must be concise. 8.50e+05. In the year 2000, what is the difference between the Aid flow (current US$) of Fragile and conflict affected situations and Aid flow (current US$) of Hungary?
Make the answer very short. 9.23e+07. In the year 2000, what is the difference between the Aid flow (current US$) in Fragile and conflict affected situations and Aid flow (current US$) in Uzbekistan?
Make the answer very short. 9.30e+07. In the year 2000, what is the difference between the Aid flow (current US$) in Hungary and Aid flow (current US$) in Uzbekistan?
Your answer should be compact. 7.10e+05. In the year 2001, what is the difference between the Aid flow (current US$) of Fragile and conflict affected situations and Aid flow (current US$) of Hungary?
Ensure brevity in your answer.  1.55e+08. In the year 2001, what is the difference between the Aid flow (current US$) of Fragile and conflict affected situations and Aid flow (current US$) of Uzbekistan?
Keep it short and to the point. 1.55e+08. In the year 2001, what is the difference between the Aid flow (current US$) of Hungary and Aid flow (current US$) of Uzbekistan?
Give a very brief answer. 1.50e+05. In the year 2003, what is the difference between the Aid flow (current US$) in Fragile and conflict affected situations and Aid flow (current US$) in Hungary?
Your response must be concise. 6.33e+08. In the year 2003, what is the difference between the Aid flow (current US$) in Fragile and conflict affected situations and Aid flow (current US$) in Uzbekistan?
Give a very brief answer. 6.34e+08. In the year 2004, what is the difference between the Aid flow (current US$) of Fragile and conflict affected situations and Aid flow (current US$) of Ecuador?
Your answer should be compact. 3.07e+08. In the year 2004, what is the difference between the Aid flow (current US$) of Fragile and conflict affected situations and Aid flow (current US$) of Hungary?
Provide a short and direct response. 3.09e+08. In the year 2004, what is the difference between the Aid flow (current US$) of Fragile and conflict affected situations and Aid flow (current US$) of Uzbekistan?
Make the answer very short. 3.09e+08. In the year 2004, what is the difference between the Aid flow (current US$) in Ecuador and Aid flow (current US$) in Hungary?
Give a very brief answer. 1.90e+06. In the year 2004, what is the difference between the Aid flow (current US$) in Ecuador and Aid flow (current US$) in Uzbekistan?
Your response must be concise. 1.92e+06. What is the ratio of the Aid flow (current US$) of Fragile and conflict affected situations in 1995 to that in 1997?
Your response must be concise. 2.2. What is the ratio of the Aid flow (current US$) in Ecuador in 1995 to that in 1997?
Ensure brevity in your answer.  0.19. What is the ratio of the Aid flow (current US$) of Hungary in 1995 to that in 1997?
Offer a terse response. 1.27. What is the ratio of the Aid flow (current US$) in Uzbekistan in 1995 to that in 1997?
Your answer should be compact. 0.01. What is the ratio of the Aid flow (current US$) of Fragile and conflict affected situations in 1995 to that in 1998?
Offer a terse response. 0.42. What is the ratio of the Aid flow (current US$) of Ecuador in 1995 to that in 1998?
Make the answer very short. 0.1. What is the ratio of the Aid flow (current US$) of Hungary in 1995 to that in 1998?
Provide a short and direct response. 1.65. What is the ratio of the Aid flow (current US$) of Fragile and conflict affected situations in 1995 to that in 1999?
Offer a terse response. 1.54. What is the ratio of the Aid flow (current US$) of Ecuador in 1995 to that in 1999?
Offer a very short reply. 0.32. What is the ratio of the Aid flow (current US$) in Hungary in 1995 to that in 1999?
Offer a very short reply. 0.37. What is the ratio of the Aid flow (current US$) in Fragile and conflict affected situations in 1995 to that in 2000?
Provide a short and direct response. 1.48. What is the ratio of the Aid flow (current US$) in Hungary in 1995 to that in 2000?
Offer a very short reply. 0.46. What is the ratio of the Aid flow (current US$) of Uzbekistan in 1995 to that in 2000?
Ensure brevity in your answer.  1. What is the ratio of the Aid flow (current US$) of Fragile and conflict affected situations in 1995 to that in 2001?
Offer a very short reply. 0.89. What is the ratio of the Aid flow (current US$) in Uzbekistan in 1995 to that in 2001?
Offer a very short reply. 0.06. What is the ratio of the Aid flow (current US$) in Fragile and conflict affected situations in 1995 to that in 2003?
Provide a short and direct response. 0.22. What is the ratio of the Aid flow (current US$) in Hungary in 1995 to that in 2003?
Provide a succinct answer. 0.85. What is the ratio of the Aid flow (current US$) in Uzbekistan in 1995 to that in 2003?
Provide a succinct answer. 0.04. What is the ratio of the Aid flow (current US$) of Fragile and conflict affected situations in 1995 to that in 2004?
Make the answer very short. 0.45. What is the ratio of the Aid flow (current US$) of Ecuador in 1995 to that in 2004?
Keep it short and to the point. 1.05. What is the ratio of the Aid flow (current US$) in Hungary in 1995 to that in 2004?
Ensure brevity in your answer.  11. What is the ratio of the Aid flow (current US$) of Uzbekistan in 1995 to that in 2004?
Your answer should be compact. 1. What is the ratio of the Aid flow (current US$) in Fragile and conflict affected situations in 1997 to that in 1998?
Keep it short and to the point. 0.19. What is the ratio of the Aid flow (current US$) in Ecuador in 1997 to that in 1998?
Make the answer very short. 0.52. What is the ratio of the Aid flow (current US$) of Uzbekistan in 1997 to that in 1998?
Your answer should be compact. 29.25. What is the ratio of the Aid flow (current US$) of Fragile and conflict affected situations in 1997 to that in 1999?
Your answer should be compact. 0.7. What is the ratio of the Aid flow (current US$) in Ecuador in 1997 to that in 1999?
Offer a very short reply. 1.69. What is the ratio of the Aid flow (current US$) in Hungary in 1997 to that in 1999?
Your answer should be compact. 0.29. What is the ratio of the Aid flow (current US$) in Uzbekistan in 1997 to that in 1999?
Offer a very short reply. 29.25. What is the ratio of the Aid flow (current US$) of Fragile and conflict affected situations in 1997 to that in 2000?
Make the answer very short. 0.67. What is the ratio of the Aid flow (current US$) in Hungary in 1997 to that in 2000?
Make the answer very short. 0.36. What is the ratio of the Aid flow (current US$) of Uzbekistan in 1997 to that in 2000?
Provide a short and direct response. 117. What is the ratio of the Aid flow (current US$) in Fragile and conflict affected situations in 1997 to that in 2001?
Make the answer very short. 0.4. What is the ratio of the Aid flow (current US$) of Hungary in 1997 to that in 2001?
Offer a very short reply. 0.79. What is the ratio of the Aid flow (current US$) in Fragile and conflict affected situations in 1997 to that in 2003?
Offer a very short reply. 0.1. What is the ratio of the Aid flow (current US$) in Uzbekistan in 1997 to that in 2003?
Provide a succinct answer. 4.88. What is the ratio of the Aid flow (current US$) in Fragile and conflict affected situations in 1997 to that in 2004?
Make the answer very short. 0.2. What is the ratio of the Aid flow (current US$) of Ecuador in 1997 to that in 2004?
Offer a terse response. 5.5. What is the ratio of the Aid flow (current US$) of Hungary in 1997 to that in 2004?
Make the answer very short. 8.67. What is the ratio of the Aid flow (current US$) of Uzbekistan in 1997 to that in 2004?
Give a very brief answer. 117. What is the ratio of the Aid flow (current US$) of Fragile and conflict affected situations in 1998 to that in 1999?
Your answer should be compact. 3.64. What is the ratio of the Aid flow (current US$) of Ecuador in 1998 to that in 1999?
Keep it short and to the point. 3.24. What is the ratio of the Aid flow (current US$) in Hungary in 1998 to that in 1999?
Ensure brevity in your answer.  0.22. What is the ratio of the Aid flow (current US$) in Fragile and conflict affected situations in 1998 to that in 2000?
Give a very brief answer. 3.51. What is the ratio of the Aid flow (current US$) of Hungary in 1998 to that in 2000?
Ensure brevity in your answer.  0.28. What is the ratio of the Aid flow (current US$) of Uzbekistan in 1998 to that in 2000?
Offer a terse response. 4. What is the ratio of the Aid flow (current US$) of Fragile and conflict affected situations in 1998 to that in 2001?
Your response must be concise. 2.11. What is the ratio of the Aid flow (current US$) of Hungary in 1998 to that in 2001?
Your response must be concise. 0.61. What is the ratio of the Aid flow (current US$) in Uzbekistan in 1998 to that in 2001?
Keep it short and to the point. 0.22. What is the ratio of the Aid flow (current US$) of Fragile and conflict affected situations in 1998 to that in 2003?
Provide a succinct answer. 0.52. What is the ratio of the Aid flow (current US$) of Hungary in 1998 to that in 2003?
Offer a terse response. 0.51. What is the ratio of the Aid flow (current US$) in Uzbekistan in 1998 to that in 2003?
Provide a succinct answer. 0.17. What is the ratio of the Aid flow (current US$) of Fragile and conflict affected situations in 1998 to that in 2004?
Your answer should be very brief. 1.06. What is the ratio of the Aid flow (current US$) in Ecuador in 1998 to that in 2004?
Provide a succinct answer. 10.51. What is the ratio of the Aid flow (current US$) of Fragile and conflict affected situations in 1999 to that in 2000?
Provide a succinct answer. 0.96. What is the ratio of the Aid flow (current US$) in Hungary in 1999 to that in 2000?
Keep it short and to the point. 1.24. What is the ratio of the Aid flow (current US$) of Uzbekistan in 1999 to that in 2000?
Your answer should be very brief. 4. What is the ratio of the Aid flow (current US$) of Fragile and conflict affected situations in 1999 to that in 2001?
Make the answer very short. 0.58. What is the ratio of the Aid flow (current US$) in Hungary in 1999 to that in 2001?
Provide a short and direct response. 2.7. What is the ratio of the Aid flow (current US$) in Uzbekistan in 1999 to that in 2001?
Your answer should be compact. 0.22. What is the ratio of the Aid flow (current US$) of Fragile and conflict affected situations in 1999 to that in 2003?
Your answer should be very brief. 0.14. What is the ratio of the Aid flow (current US$) in Hungary in 1999 to that in 2003?
Your answer should be compact. 2.28. What is the ratio of the Aid flow (current US$) of Uzbekistan in 1999 to that in 2003?
Your answer should be compact. 0.17. What is the ratio of the Aid flow (current US$) of Fragile and conflict affected situations in 1999 to that in 2004?
Provide a succinct answer. 0.29. What is the ratio of the Aid flow (current US$) in Ecuador in 1999 to that in 2004?
Give a very brief answer. 3.24. What is the ratio of the Aid flow (current US$) in Hungary in 1999 to that in 2004?
Give a very brief answer. 29.67. What is the ratio of the Aid flow (current US$) in Uzbekistan in 1999 to that in 2004?
Your response must be concise. 4. What is the ratio of the Aid flow (current US$) of Fragile and conflict affected situations in 2000 to that in 2001?
Ensure brevity in your answer.  0.6. What is the ratio of the Aid flow (current US$) in Hungary in 2000 to that in 2001?
Keep it short and to the point. 2.18. What is the ratio of the Aid flow (current US$) in Uzbekistan in 2000 to that in 2001?
Ensure brevity in your answer.  0.06. What is the ratio of the Aid flow (current US$) of Fragile and conflict affected situations in 2000 to that in 2003?
Your answer should be compact. 0.15. What is the ratio of the Aid flow (current US$) of Hungary in 2000 to that in 2003?
Give a very brief answer. 1.85. What is the ratio of the Aid flow (current US$) in Uzbekistan in 2000 to that in 2003?
Ensure brevity in your answer.  0.04. What is the ratio of the Aid flow (current US$) of Fragile and conflict affected situations in 2000 to that in 2004?
Offer a very short reply. 0.3. What is the ratio of the Aid flow (current US$) of Fragile and conflict affected situations in 2001 to that in 2003?
Give a very brief answer. 0.24. What is the ratio of the Aid flow (current US$) of Hungary in 2001 to that in 2003?
Offer a terse response. 0.85. What is the ratio of the Aid flow (current US$) in Fragile and conflict affected situations in 2001 to that in 2004?
Make the answer very short. 0.5. What is the ratio of the Aid flow (current US$) in Hungary in 2001 to that in 2004?
Your response must be concise. 11. What is the ratio of the Aid flow (current US$) of Fragile and conflict affected situations in 2003 to that in 2004?
Keep it short and to the point. 2.05. What is the difference between the highest and the second highest Aid flow (current US$) in Fragile and conflict affected situations?
Give a very brief answer. 3.07e+08. What is the difference between the highest and the second highest Aid flow (current US$) in Ecuador?
Your response must be concise. 9.68e+06. What is the difference between the highest and the second highest Aid flow (current US$) of Hungary?
Ensure brevity in your answer.  1.70e+05. What is the difference between the highest and the second highest Aid flow (current US$) in Uzbekistan?
Your response must be concise. 9.30e+05. What is the difference between the highest and the lowest Aid flow (current US$) in Fragile and conflict affected situations?
Offer a terse response. 5.71e+08. What is the difference between the highest and the lowest Aid flow (current US$) of Ecuador?
Offer a very short reply. 2.03e+07. What is the difference between the highest and the lowest Aid flow (current US$) in Hungary?
Keep it short and to the point. 8.60e+05. What is the difference between the highest and the lowest Aid flow (current US$) in Uzbekistan?
Your answer should be compact. 1.16e+06. 